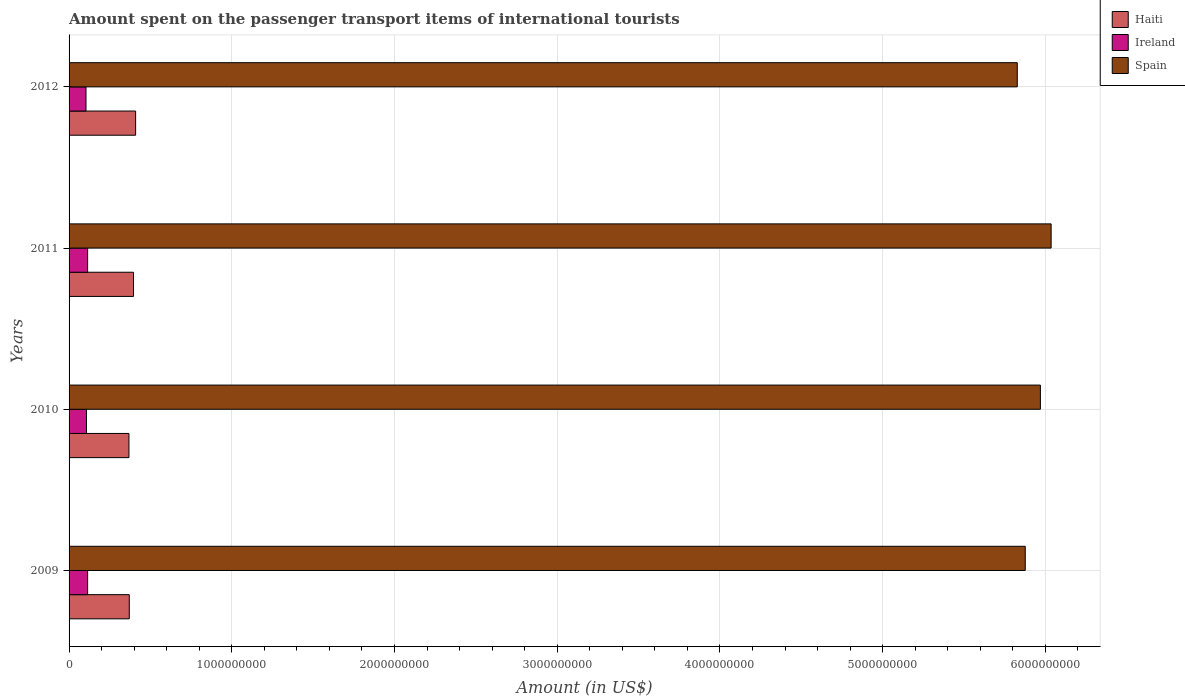How many groups of bars are there?
Provide a short and direct response. 4. Are the number of bars per tick equal to the number of legend labels?
Your response must be concise. Yes. Are the number of bars on each tick of the Y-axis equal?
Make the answer very short. Yes. What is the label of the 3rd group of bars from the top?
Your response must be concise. 2010. What is the amount spent on the passenger transport items of international tourists in Ireland in 2009?
Your answer should be very brief. 1.14e+08. Across all years, what is the maximum amount spent on the passenger transport items of international tourists in Ireland?
Your response must be concise. 1.14e+08. Across all years, what is the minimum amount spent on the passenger transport items of international tourists in Ireland?
Your answer should be very brief. 1.04e+08. In which year was the amount spent on the passenger transport items of international tourists in Spain minimum?
Keep it short and to the point. 2012. What is the total amount spent on the passenger transport items of international tourists in Spain in the graph?
Ensure brevity in your answer.  2.37e+1. What is the difference between the amount spent on the passenger transport items of international tourists in Haiti in 2010 and that in 2011?
Offer a terse response. -2.80e+07. What is the difference between the amount spent on the passenger transport items of international tourists in Spain in 2010 and the amount spent on the passenger transport items of international tourists in Haiti in 2009?
Your answer should be compact. 5.60e+09. What is the average amount spent on the passenger transport items of international tourists in Ireland per year?
Offer a terse response. 1.10e+08. In the year 2011, what is the difference between the amount spent on the passenger transport items of international tourists in Ireland and amount spent on the passenger transport items of international tourists in Spain?
Provide a short and direct response. -5.92e+09. What is the ratio of the amount spent on the passenger transport items of international tourists in Haiti in 2010 to that in 2012?
Offer a very short reply. 0.9. Is the amount spent on the passenger transport items of international tourists in Ireland in 2009 less than that in 2011?
Ensure brevity in your answer.  No. What is the difference between the highest and the second highest amount spent on the passenger transport items of international tourists in Haiti?
Offer a terse response. 1.30e+07. Is the sum of the amount spent on the passenger transport items of international tourists in Ireland in 2009 and 2012 greater than the maximum amount spent on the passenger transport items of international tourists in Spain across all years?
Your answer should be compact. No. What does the 2nd bar from the top in 2010 represents?
Your response must be concise. Ireland. What does the 2nd bar from the bottom in 2012 represents?
Keep it short and to the point. Ireland. Is it the case that in every year, the sum of the amount spent on the passenger transport items of international tourists in Spain and amount spent on the passenger transport items of international tourists in Ireland is greater than the amount spent on the passenger transport items of international tourists in Haiti?
Keep it short and to the point. Yes. How many bars are there?
Your answer should be compact. 12. Are the values on the major ticks of X-axis written in scientific E-notation?
Provide a short and direct response. No. Does the graph contain grids?
Provide a short and direct response. Yes. How many legend labels are there?
Your response must be concise. 3. How are the legend labels stacked?
Make the answer very short. Vertical. What is the title of the graph?
Your answer should be very brief. Amount spent on the passenger transport items of international tourists. Does "Trinidad and Tobago" appear as one of the legend labels in the graph?
Provide a short and direct response. No. What is the Amount (in US$) in Haiti in 2009?
Your response must be concise. 3.70e+08. What is the Amount (in US$) in Ireland in 2009?
Offer a terse response. 1.14e+08. What is the Amount (in US$) of Spain in 2009?
Offer a terse response. 5.88e+09. What is the Amount (in US$) of Haiti in 2010?
Make the answer very short. 3.68e+08. What is the Amount (in US$) of Ireland in 2010?
Ensure brevity in your answer.  1.07e+08. What is the Amount (in US$) in Spain in 2010?
Provide a short and direct response. 5.97e+09. What is the Amount (in US$) of Haiti in 2011?
Your answer should be compact. 3.96e+08. What is the Amount (in US$) of Ireland in 2011?
Offer a very short reply. 1.14e+08. What is the Amount (in US$) of Spain in 2011?
Offer a very short reply. 6.04e+09. What is the Amount (in US$) of Haiti in 2012?
Your answer should be very brief. 4.09e+08. What is the Amount (in US$) in Ireland in 2012?
Keep it short and to the point. 1.04e+08. What is the Amount (in US$) in Spain in 2012?
Provide a short and direct response. 5.83e+09. Across all years, what is the maximum Amount (in US$) of Haiti?
Give a very brief answer. 4.09e+08. Across all years, what is the maximum Amount (in US$) in Ireland?
Your answer should be compact. 1.14e+08. Across all years, what is the maximum Amount (in US$) of Spain?
Provide a short and direct response. 6.04e+09. Across all years, what is the minimum Amount (in US$) of Haiti?
Give a very brief answer. 3.68e+08. Across all years, what is the minimum Amount (in US$) in Ireland?
Provide a succinct answer. 1.04e+08. Across all years, what is the minimum Amount (in US$) in Spain?
Keep it short and to the point. 5.83e+09. What is the total Amount (in US$) of Haiti in the graph?
Provide a short and direct response. 1.54e+09. What is the total Amount (in US$) of Ireland in the graph?
Offer a terse response. 4.39e+08. What is the total Amount (in US$) in Spain in the graph?
Give a very brief answer. 2.37e+1. What is the difference between the Amount (in US$) in Haiti in 2009 and that in 2010?
Your response must be concise. 2.00e+06. What is the difference between the Amount (in US$) in Spain in 2009 and that in 2010?
Offer a terse response. -9.30e+07. What is the difference between the Amount (in US$) in Haiti in 2009 and that in 2011?
Provide a succinct answer. -2.60e+07. What is the difference between the Amount (in US$) in Spain in 2009 and that in 2011?
Keep it short and to the point. -1.59e+08. What is the difference between the Amount (in US$) in Haiti in 2009 and that in 2012?
Provide a short and direct response. -3.90e+07. What is the difference between the Amount (in US$) of Spain in 2009 and that in 2012?
Ensure brevity in your answer.  4.90e+07. What is the difference between the Amount (in US$) in Haiti in 2010 and that in 2011?
Give a very brief answer. -2.80e+07. What is the difference between the Amount (in US$) in Ireland in 2010 and that in 2011?
Your answer should be very brief. -7.00e+06. What is the difference between the Amount (in US$) in Spain in 2010 and that in 2011?
Keep it short and to the point. -6.60e+07. What is the difference between the Amount (in US$) in Haiti in 2010 and that in 2012?
Provide a succinct answer. -4.10e+07. What is the difference between the Amount (in US$) of Spain in 2010 and that in 2012?
Provide a succinct answer. 1.42e+08. What is the difference between the Amount (in US$) in Haiti in 2011 and that in 2012?
Provide a succinct answer. -1.30e+07. What is the difference between the Amount (in US$) in Spain in 2011 and that in 2012?
Keep it short and to the point. 2.08e+08. What is the difference between the Amount (in US$) in Haiti in 2009 and the Amount (in US$) in Ireland in 2010?
Offer a very short reply. 2.63e+08. What is the difference between the Amount (in US$) in Haiti in 2009 and the Amount (in US$) in Spain in 2010?
Keep it short and to the point. -5.60e+09. What is the difference between the Amount (in US$) of Ireland in 2009 and the Amount (in US$) of Spain in 2010?
Offer a terse response. -5.86e+09. What is the difference between the Amount (in US$) in Haiti in 2009 and the Amount (in US$) in Ireland in 2011?
Offer a terse response. 2.56e+08. What is the difference between the Amount (in US$) in Haiti in 2009 and the Amount (in US$) in Spain in 2011?
Provide a succinct answer. -5.66e+09. What is the difference between the Amount (in US$) of Ireland in 2009 and the Amount (in US$) of Spain in 2011?
Provide a short and direct response. -5.92e+09. What is the difference between the Amount (in US$) of Haiti in 2009 and the Amount (in US$) of Ireland in 2012?
Provide a short and direct response. 2.66e+08. What is the difference between the Amount (in US$) in Haiti in 2009 and the Amount (in US$) in Spain in 2012?
Provide a succinct answer. -5.46e+09. What is the difference between the Amount (in US$) of Ireland in 2009 and the Amount (in US$) of Spain in 2012?
Provide a short and direct response. -5.71e+09. What is the difference between the Amount (in US$) in Haiti in 2010 and the Amount (in US$) in Ireland in 2011?
Offer a terse response. 2.54e+08. What is the difference between the Amount (in US$) in Haiti in 2010 and the Amount (in US$) in Spain in 2011?
Keep it short and to the point. -5.67e+09. What is the difference between the Amount (in US$) in Ireland in 2010 and the Amount (in US$) in Spain in 2011?
Keep it short and to the point. -5.93e+09. What is the difference between the Amount (in US$) of Haiti in 2010 and the Amount (in US$) of Ireland in 2012?
Keep it short and to the point. 2.64e+08. What is the difference between the Amount (in US$) in Haiti in 2010 and the Amount (in US$) in Spain in 2012?
Keep it short and to the point. -5.46e+09. What is the difference between the Amount (in US$) in Ireland in 2010 and the Amount (in US$) in Spain in 2012?
Your response must be concise. -5.72e+09. What is the difference between the Amount (in US$) in Haiti in 2011 and the Amount (in US$) in Ireland in 2012?
Offer a very short reply. 2.92e+08. What is the difference between the Amount (in US$) in Haiti in 2011 and the Amount (in US$) in Spain in 2012?
Your answer should be compact. -5.43e+09. What is the difference between the Amount (in US$) of Ireland in 2011 and the Amount (in US$) of Spain in 2012?
Keep it short and to the point. -5.71e+09. What is the average Amount (in US$) of Haiti per year?
Ensure brevity in your answer.  3.86e+08. What is the average Amount (in US$) in Ireland per year?
Your response must be concise. 1.10e+08. What is the average Amount (in US$) of Spain per year?
Offer a terse response. 5.93e+09. In the year 2009, what is the difference between the Amount (in US$) in Haiti and Amount (in US$) in Ireland?
Offer a terse response. 2.56e+08. In the year 2009, what is the difference between the Amount (in US$) in Haiti and Amount (in US$) in Spain?
Your answer should be very brief. -5.51e+09. In the year 2009, what is the difference between the Amount (in US$) in Ireland and Amount (in US$) in Spain?
Offer a terse response. -5.76e+09. In the year 2010, what is the difference between the Amount (in US$) of Haiti and Amount (in US$) of Ireland?
Offer a terse response. 2.61e+08. In the year 2010, what is the difference between the Amount (in US$) of Haiti and Amount (in US$) of Spain?
Your response must be concise. -5.60e+09. In the year 2010, what is the difference between the Amount (in US$) of Ireland and Amount (in US$) of Spain?
Give a very brief answer. -5.86e+09. In the year 2011, what is the difference between the Amount (in US$) in Haiti and Amount (in US$) in Ireland?
Keep it short and to the point. 2.82e+08. In the year 2011, what is the difference between the Amount (in US$) in Haiti and Amount (in US$) in Spain?
Your answer should be compact. -5.64e+09. In the year 2011, what is the difference between the Amount (in US$) in Ireland and Amount (in US$) in Spain?
Offer a terse response. -5.92e+09. In the year 2012, what is the difference between the Amount (in US$) in Haiti and Amount (in US$) in Ireland?
Ensure brevity in your answer.  3.05e+08. In the year 2012, what is the difference between the Amount (in US$) of Haiti and Amount (in US$) of Spain?
Provide a succinct answer. -5.42e+09. In the year 2012, what is the difference between the Amount (in US$) of Ireland and Amount (in US$) of Spain?
Offer a very short reply. -5.72e+09. What is the ratio of the Amount (in US$) in Haiti in 2009 to that in 2010?
Provide a succinct answer. 1.01. What is the ratio of the Amount (in US$) in Ireland in 2009 to that in 2010?
Keep it short and to the point. 1.07. What is the ratio of the Amount (in US$) of Spain in 2009 to that in 2010?
Ensure brevity in your answer.  0.98. What is the ratio of the Amount (in US$) of Haiti in 2009 to that in 2011?
Provide a succinct answer. 0.93. What is the ratio of the Amount (in US$) of Ireland in 2009 to that in 2011?
Offer a terse response. 1. What is the ratio of the Amount (in US$) in Spain in 2009 to that in 2011?
Your answer should be compact. 0.97. What is the ratio of the Amount (in US$) of Haiti in 2009 to that in 2012?
Give a very brief answer. 0.9. What is the ratio of the Amount (in US$) of Ireland in 2009 to that in 2012?
Your answer should be very brief. 1.1. What is the ratio of the Amount (in US$) in Spain in 2009 to that in 2012?
Make the answer very short. 1.01. What is the ratio of the Amount (in US$) in Haiti in 2010 to that in 2011?
Offer a very short reply. 0.93. What is the ratio of the Amount (in US$) in Ireland in 2010 to that in 2011?
Provide a short and direct response. 0.94. What is the ratio of the Amount (in US$) in Haiti in 2010 to that in 2012?
Offer a terse response. 0.9. What is the ratio of the Amount (in US$) of Ireland in 2010 to that in 2012?
Provide a short and direct response. 1.03. What is the ratio of the Amount (in US$) of Spain in 2010 to that in 2012?
Make the answer very short. 1.02. What is the ratio of the Amount (in US$) of Haiti in 2011 to that in 2012?
Your response must be concise. 0.97. What is the ratio of the Amount (in US$) of Ireland in 2011 to that in 2012?
Provide a succinct answer. 1.1. What is the ratio of the Amount (in US$) in Spain in 2011 to that in 2012?
Make the answer very short. 1.04. What is the difference between the highest and the second highest Amount (in US$) in Haiti?
Your answer should be compact. 1.30e+07. What is the difference between the highest and the second highest Amount (in US$) in Spain?
Your answer should be compact. 6.60e+07. What is the difference between the highest and the lowest Amount (in US$) in Haiti?
Ensure brevity in your answer.  4.10e+07. What is the difference between the highest and the lowest Amount (in US$) in Ireland?
Your response must be concise. 1.00e+07. What is the difference between the highest and the lowest Amount (in US$) in Spain?
Offer a very short reply. 2.08e+08. 